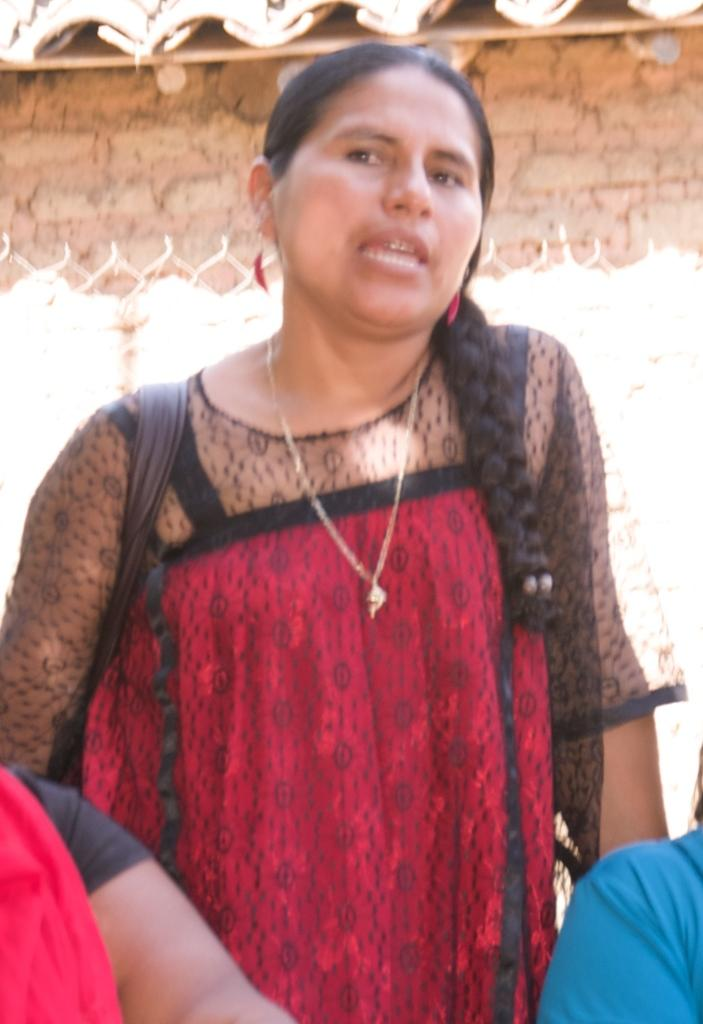Who or what can be seen in the image? There are people in the image. What type of structure is present in the image? There is a fence in the image. What other architectural feature can be seen in the image? There is a wall in the image. What type of steam can be seen coming from the people in the image? There is no steam present in the image; it features people, a fence, and a wall. What vein is visible on the wall in the image? There is no vein present on the wall in the image. 